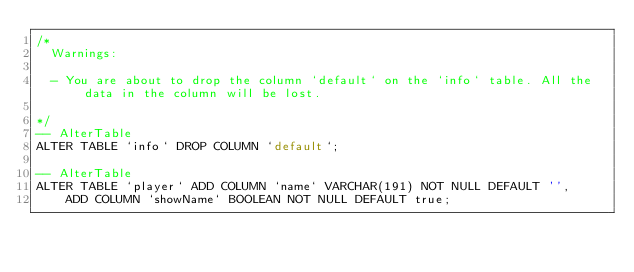Convert code to text. <code><loc_0><loc_0><loc_500><loc_500><_SQL_>/*
  Warnings:

  - You are about to drop the column `default` on the `info` table. All the data in the column will be lost.

*/
-- AlterTable
ALTER TABLE `info` DROP COLUMN `default`;

-- AlterTable
ALTER TABLE `player` ADD COLUMN `name` VARCHAR(191) NOT NULL DEFAULT '',
    ADD COLUMN `showName` BOOLEAN NOT NULL DEFAULT true;
</code> 